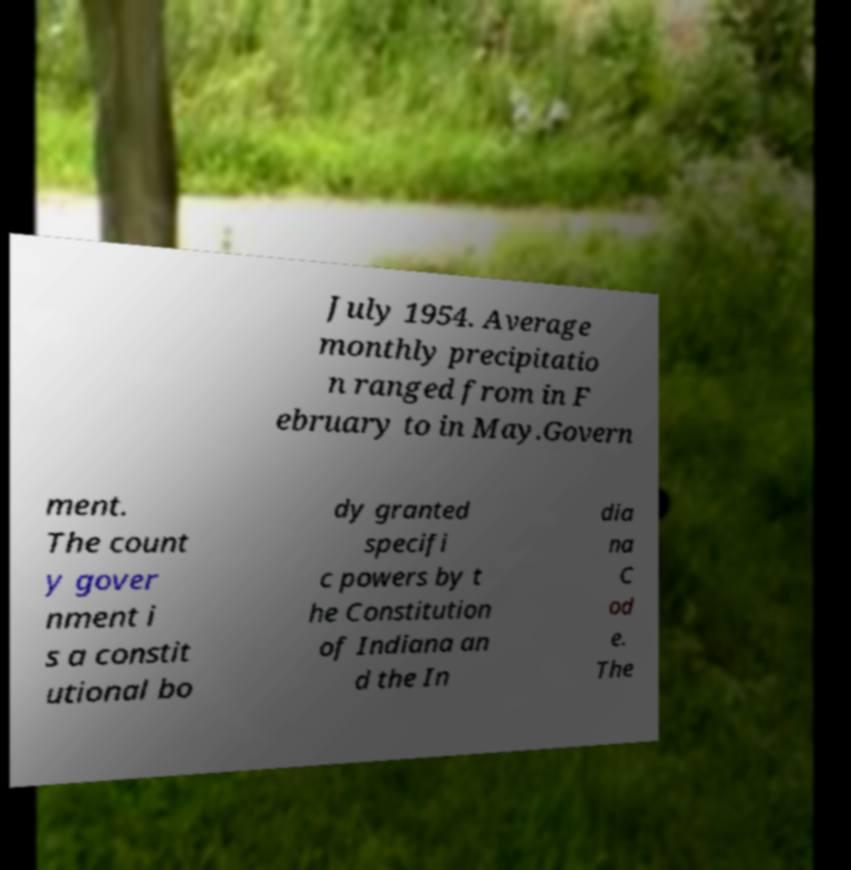Please read and relay the text visible in this image. What does it say? July 1954. Average monthly precipitatio n ranged from in F ebruary to in May.Govern ment. The count y gover nment i s a constit utional bo dy granted specifi c powers by t he Constitution of Indiana an d the In dia na C od e. The 